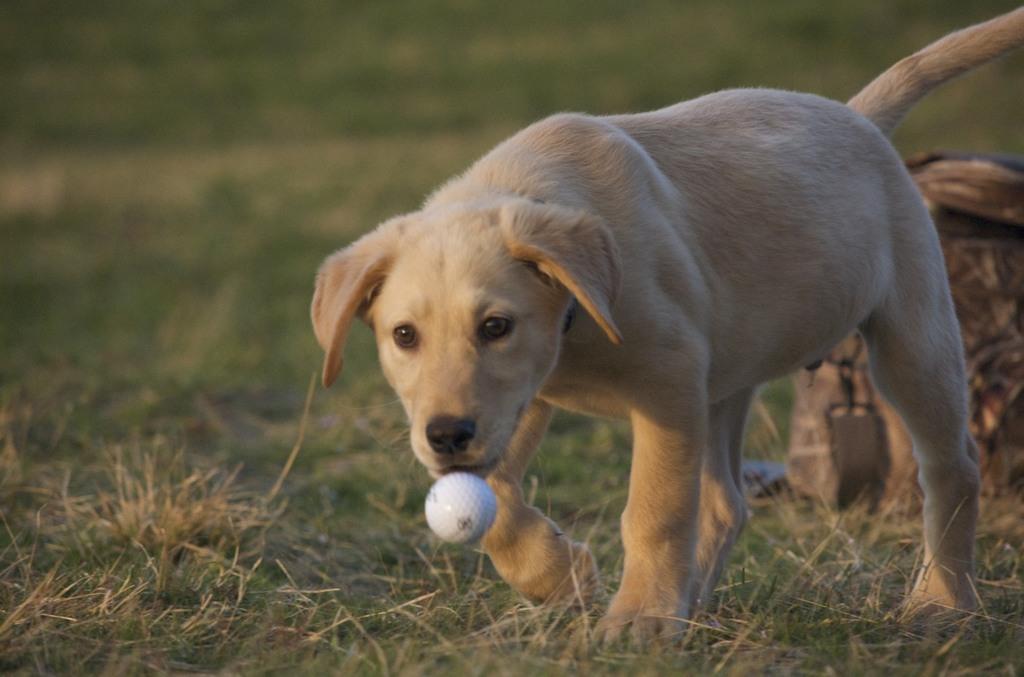Could you give a brief overview of what you see in this image? In this picture there is a dog in the center of the image on the grassland and there is a ball at the bottom side of the image and there is a log in the background area of the image. 